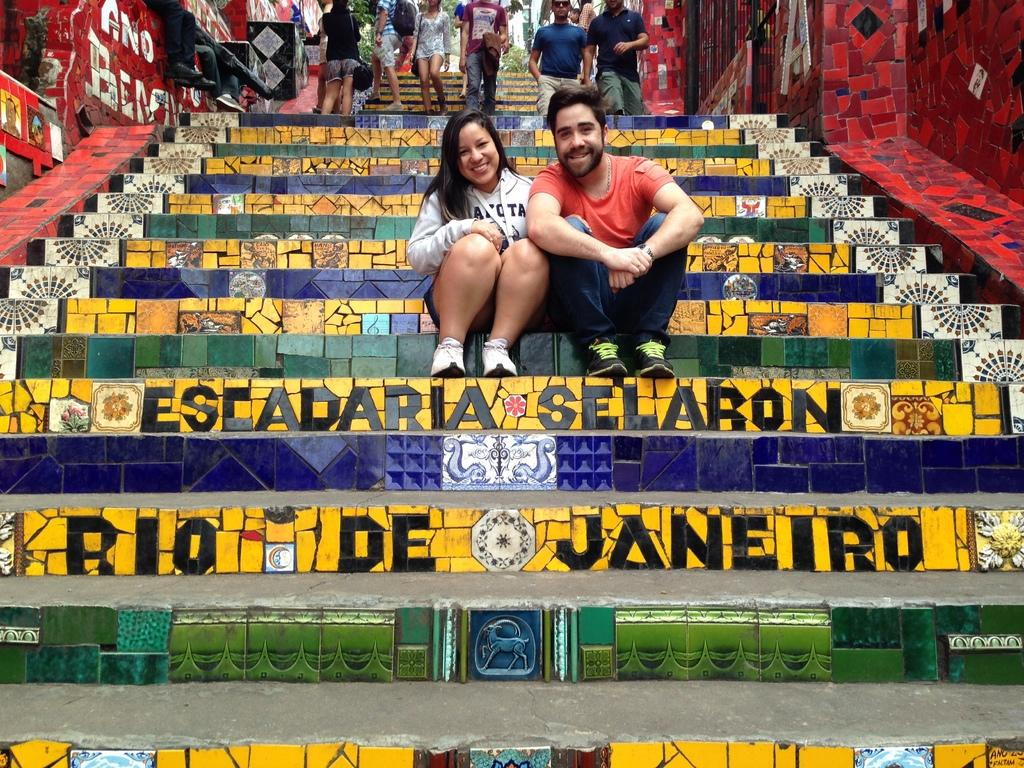What are the two main subjects in the image? There is a man and a woman sitting on the steps in the image. Can you describe the setting of the image? There are steps visible in the background of the image, along with persons, trees, and buildings. How many people are visible in the image? There are at least two people, the man and the woman sitting on the steps, and additional persons in the background. What type of jeans is the man wearing in the image? The image does not provide information about the man's clothing, so it cannot be determined if he is wearing jeans or any other type of clothing. 